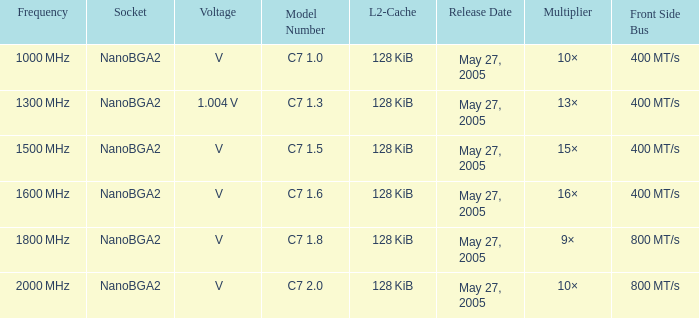What is the launch date for model number c7 May 27, 2005. 